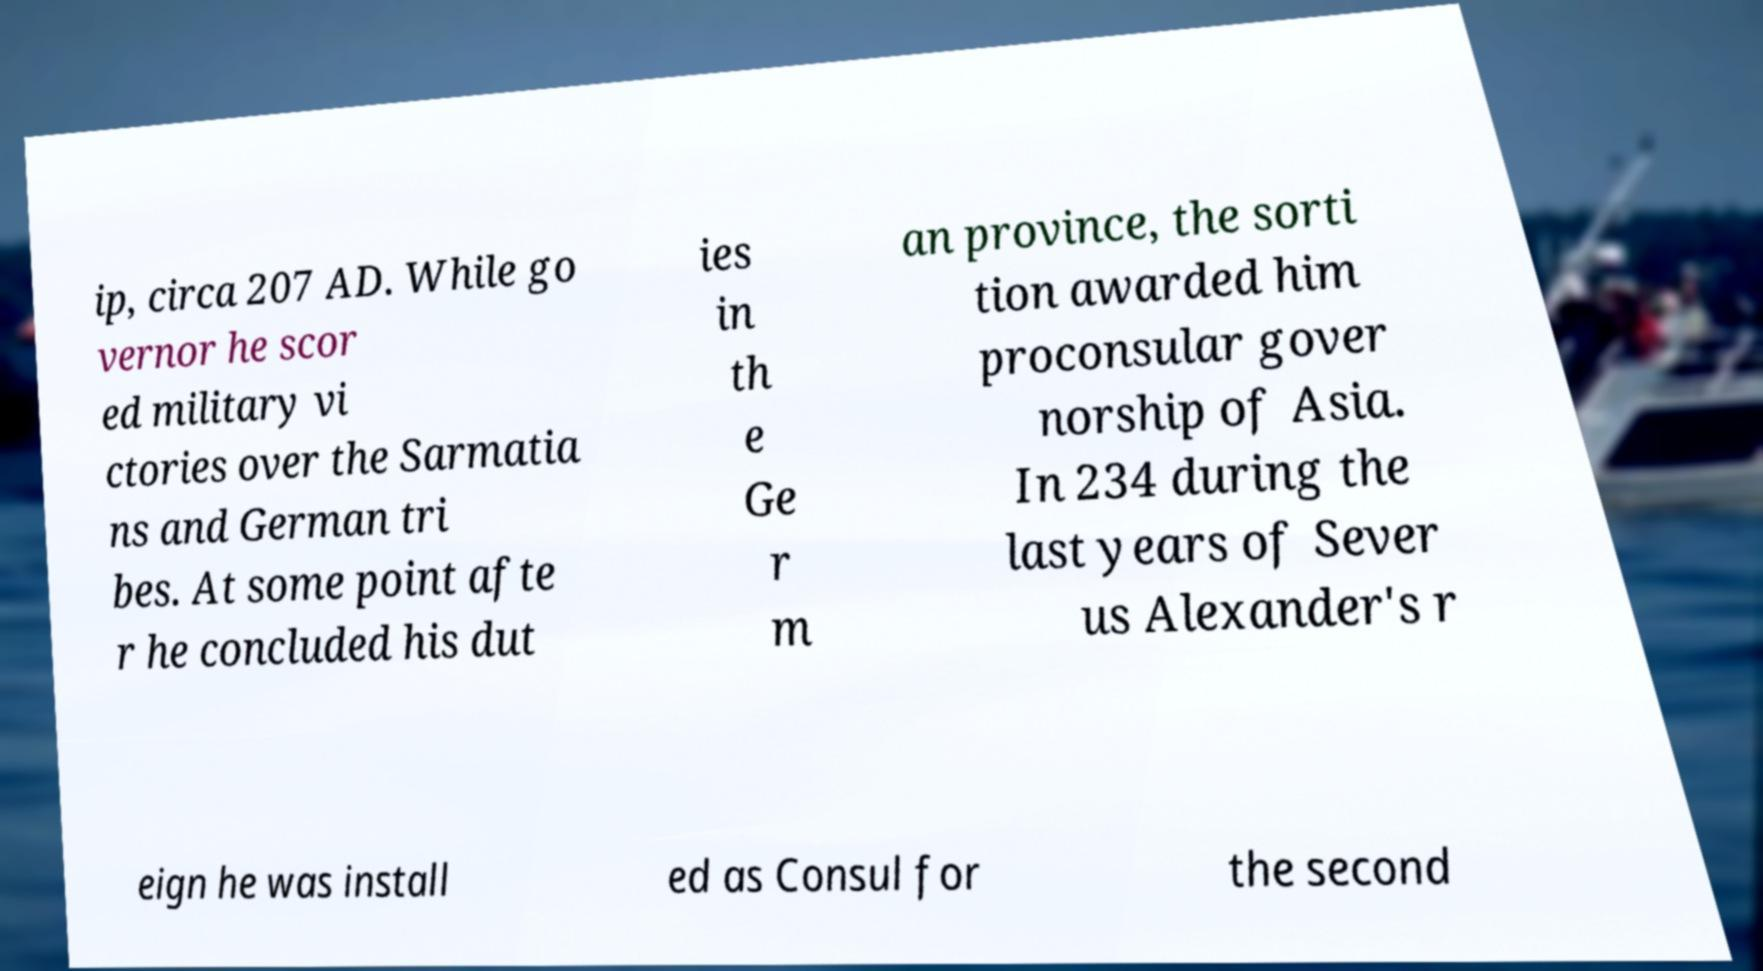Can you read and provide the text displayed in the image?This photo seems to have some interesting text. Can you extract and type it out for me? ip, circa 207 AD. While go vernor he scor ed military vi ctories over the Sarmatia ns and German tri bes. At some point afte r he concluded his dut ies in th e Ge r m an province, the sorti tion awarded him proconsular gover norship of Asia. In 234 during the last years of Sever us Alexander's r eign he was install ed as Consul for the second 